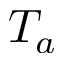<formula> <loc_0><loc_0><loc_500><loc_500>T _ { a }</formula> 